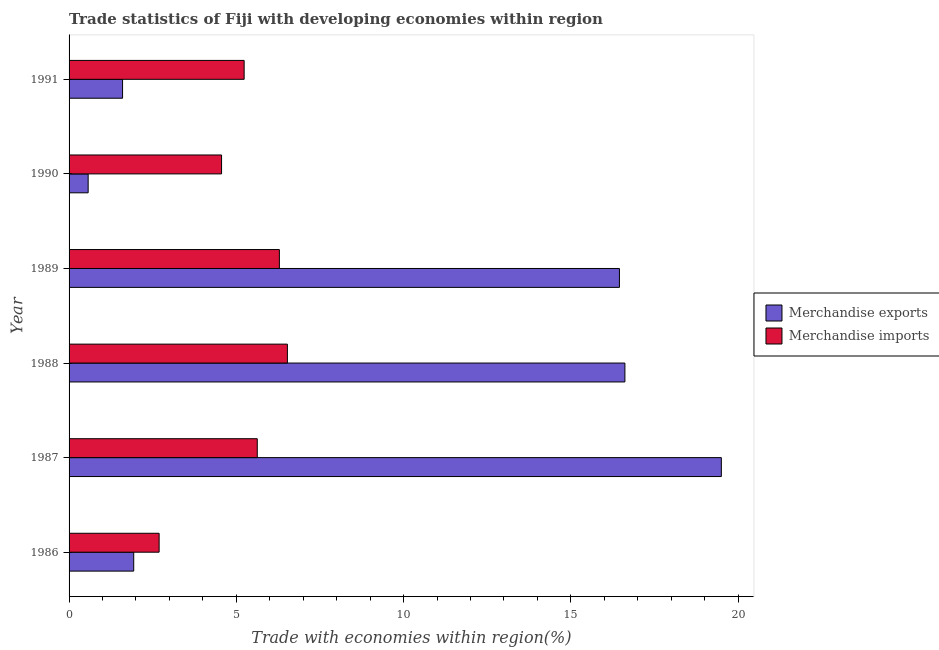How many different coloured bars are there?
Your response must be concise. 2. How many groups of bars are there?
Make the answer very short. 6. Are the number of bars on each tick of the Y-axis equal?
Give a very brief answer. Yes. How many bars are there on the 3rd tick from the top?
Provide a succinct answer. 2. In how many cases, is the number of bars for a given year not equal to the number of legend labels?
Provide a short and direct response. 0. What is the merchandise imports in 1987?
Keep it short and to the point. 5.63. Across all years, what is the maximum merchandise imports?
Your answer should be compact. 6.53. Across all years, what is the minimum merchandise imports?
Your answer should be very brief. 2.69. What is the total merchandise exports in the graph?
Keep it short and to the point. 56.67. What is the difference between the merchandise exports in 1987 and that in 1989?
Ensure brevity in your answer.  3.05. What is the difference between the merchandise exports in 1990 and the merchandise imports in 1987?
Ensure brevity in your answer.  -5.06. What is the average merchandise imports per year?
Give a very brief answer. 5.15. In the year 1987, what is the difference between the merchandise exports and merchandise imports?
Provide a succinct answer. 13.87. What is the ratio of the merchandise exports in 1988 to that in 1989?
Provide a short and direct response. 1.01. Is the merchandise imports in 1986 less than that in 1991?
Provide a short and direct response. Yes. What is the difference between the highest and the second highest merchandise imports?
Your answer should be compact. 0.24. What is the difference between the highest and the lowest merchandise exports?
Your response must be concise. 18.93. In how many years, is the merchandise exports greater than the average merchandise exports taken over all years?
Offer a terse response. 3. Is the sum of the merchandise exports in 1986 and 1989 greater than the maximum merchandise imports across all years?
Provide a short and direct response. Yes. What does the 2nd bar from the top in 1989 represents?
Provide a short and direct response. Merchandise exports. What does the 2nd bar from the bottom in 1986 represents?
Offer a very short reply. Merchandise imports. How many bars are there?
Offer a very short reply. 12. Are all the bars in the graph horizontal?
Your response must be concise. Yes. Does the graph contain any zero values?
Your answer should be very brief. No. Does the graph contain grids?
Make the answer very short. No. How are the legend labels stacked?
Provide a succinct answer. Vertical. What is the title of the graph?
Your response must be concise. Trade statistics of Fiji with developing economies within region. Does "Export" appear as one of the legend labels in the graph?
Your answer should be compact. No. What is the label or title of the X-axis?
Offer a terse response. Trade with economies within region(%). What is the Trade with economies within region(%) of Merchandise exports in 1986?
Make the answer very short. 1.93. What is the Trade with economies within region(%) of Merchandise imports in 1986?
Provide a short and direct response. 2.69. What is the Trade with economies within region(%) in Merchandise exports in 1987?
Your answer should be very brief. 19.5. What is the Trade with economies within region(%) in Merchandise imports in 1987?
Give a very brief answer. 5.63. What is the Trade with economies within region(%) in Merchandise exports in 1988?
Keep it short and to the point. 16.62. What is the Trade with economies within region(%) in Merchandise imports in 1988?
Your answer should be compact. 6.53. What is the Trade with economies within region(%) in Merchandise exports in 1989?
Your response must be concise. 16.45. What is the Trade with economies within region(%) of Merchandise imports in 1989?
Provide a short and direct response. 6.29. What is the Trade with economies within region(%) in Merchandise exports in 1990?
Your answer should be compact. 0.57. What is the Trade with economies within region(%) of Merchandise imports in 1990?
Your answer should be very brief. 4.56. What is the Trade with economies within region(%) of Merchandise exports in 1991?
Provide a succinct answer. 1.6. What is the Trade with economies within region(%) in Merchandise imports in 1991?
Provide a succinct answer. 5.23. Across all years, what is the maximum Trade with economies within region(%) of Merchandise exports?
Make the answer very short. 19.5. Across all years, what is the maximum Trade with economies within region(%) of Merchandise imports?
Your answer should be compact. 6.53. Across all years, what is the minimum Trade with economies within region(%) in Merchandise exports?
Your answer should be very brief. 0.57. Across all years, what is the minimum Trade with economies within region(%) of Merchandise imports?
Make the answer very short. 2.69. What is the total Trade with economies within region(%) in Merchandise exports in the graph?
Keep it short and to the point. 56.67. What is the total Trade with economies within region(%) of Merchandise imports in the graph?
Give a very brief answer. 30.92. What is the difference between the Trade with economies within region(%) of Merchandise exports in 1986 and that in 1987?
Make the answer very short. -17.57. What is the difference between the Trade with economies within region(%) in Merchandise imports in 1986 and that in 1987?
Keep it short and to the point. -2.93. What is the difference between the Trade with economies within region(%) of Merchandise exports in 1986 and that in 1988?
Ensure brevity in your answer.  -14.68. What is the difference between the Trade with economies within region(%) in Merchandise imports in 1986 and that in 1988?
Ensure brevity in your answer.  -3.83. What is the difference between the Trade with economies within region(%) in Merchandise exports in 1986 and that in 1989?
Offer a very short reply. -14.52. What is the difference between the Trade with economies within region(%) in Merchandise imports in 1986 and that in 1989?
Your answer should be compact. -3.59. What is the difference between the Trade with economies within region(%) of Merchandise exports in 1986 and that in 1990?
Your answer should be compact. 1.36. What is the difference between the Trade with economies within region(%) in Merchandise imports in 1986 and that in 1990?
Your answer should be compact. -1.87. What is the difference between the Trade with economies within region(%) in Merchandise exports in 1986 and that in 1991?
Your response must be concise. 0.33. What is the difference between the Trade with economies within region(%) of Merchandise imports in 1986 and that in 1991?
Your response must be concise. -2.54. What is the difference between the Trade with economies within region(%) of Merchandise exports in 1987 and that in 1988?
Provide a short and direct response. 2.88. What is the difference between the Trade with economies within region(%) of Merchandise imports in 1987 and that in 1988?
Offer a terse response. -0.9. What is the difference between the Trade with economies within region(%) in Merchandise exports in 1987 and that in 1989?
Give a very brief answer. 3.05. What is the difference between the Trade with economies within region(%) of Merchandise imports in 1987 and that in 1989?
Offer a very short reply. -0.66. What is the difference between the Trade with economies within region(%) in Merchandise exports in 1987 and that in 1990?
Offer a terse response. 18.93. What is the difference between the Trade with economies within region(%) in Merchandise imports in 1987 and that in 1990?
Offer a terse response. 1.07. What is the difference between the Trade with economies within region(%) in Merchandise exports in 1987 and that in 1991?
Make the answer very short. 17.9. What is the difference between the Trade with economies within region(%) of Merchandise imports in 1987 and that in 1991?
Offer a very short reply. 0.39. What is the difference between the Trade with economies within region(%) of Merchandise exports in 1988 and that in 1989?
Give a very brief answer. 0.16. What is the difference between the Trade with economies within region(%) of Merchandise imports in 1988 and that in 1989?
Offer a terse response. 0.24. What is the difference between the Trade with economies within region(%) of Merchandise exports in 1988 and that in 1990?
Ensure brevity in your answer.  16.04. What is the difference between the Trade with economies within region(%) of Merchandise imports in 1988 and that in 1990?
Provide a succinct answer. 1.97. What is the difference between the Trade with economies within region(%) of Merchandise exports in 1988 and that in 1991?
Provide a short and direct response. 15.02. What is the difference between the Trade with economies within region(%) of Merchandise imports in 1988 and that in 1991?
Provide a succinct answer. 1.29. What is the difference between the Trade with economies within region(%) of Merchandise exports in 1989 and that in 1990?
Offer a terse response. 15.88. What is the difference between the Trade with economies within region(%) of Merchandise imports in 1989 and that in 1990?
Your answer should be very brief. 1.73. What is the difference between the Trade with economies within region(%) of Merchandise exports in 1989 and that in 1991?
Provide a short and direct response. 14.85. What is the difference between the Trade with economies within region(%) in Merchandise imports in 1989 and that in 1991?
Offer a terse response. 1.05. What is the difference between the Trade with economies within region(%) of Merchandise exports in 1990 and that in 1991?
Your answer should be compact. -1.03. What is the difference between the Trade with economies within region(%) of Merchandise imports in 1990 and that in 1991?
Your response must be concise. -0.68. What is the difference between the Trade with economies within region(%) in Merchandise exports in 1986 and the Trade with economies within region(%) in Merchandise imports in 1987?
Provide a succinct answer. -3.69. What is the difference between the Trade with economies within region(%) of Merchandise exports in 1986 and the Trade with economies within region(%) of Merchandise imports in 1988?
Ensure brevity in your answer.  -4.59. What is the difference between the Trade with economies within region(%) in Merchandise exports in 1986 and the Trade with economies within region(%) in Merchandise imports in 1989?
Offer a very short reply. -4.35. What is the difference between the Trade with economies within region(%) in Merchandise exports in 1986 and the Trade with economies within region(%) in Merchandise imports in 1990?
Offer a terse response. -2.63. What is the difference between the Trade with economies within region(%) of Merchandise exports in 1986 and the Trade with economies within region(%) of Merchandise imports in 1991?
Provide a succinct answer. -3.3. What is the difference between the Trade with economies within region(%) of Merchandise exports in 1987 and the Trade with economies within region(%) of Merchandise imports in 1988?
Keep it short and to the point. 12.97. What is the difference between the Trade with economies within region(%) of Merchandise exports in 1987 and the Trade with economies within region(%) of Merchandise imports in 1989?
Keep it short and to the point. 13.21. What is the difference between the Trade with economies within region(%) in Merchandise exports in 1987 and the Trade with economies within region(%) in Merchandise imports in 1990?
Make the answer very short. 14.94. What is the difference between the Trade with economies within region(%) in Merchandise exports in 1987 and the Trade with economies within region(%) in Merchandise imports in 1991?
Make the answer very short. 14.26. What is the difference between the Trade with economies within region(%) in Merchandise exports in 1988 and the Trade with economies within region(%) in Merchandise imports in 1989?
Offer a very short reply. 10.33. What is the difference between the Trade with economies within region(%) of Merchandise exports in 1988 and the Trade with economies within region(%) of Merchandise imports in 1990?
Provide a succinct answer. 12.06. What is the difference between the Trade with economies within region(%) in Merchandise exports in 1988 and the Trade with economies within region(%) in Merchandise imports in 1991?
Your answer should be compact. 11.38. What is the difference between the Trade with economies within region(%) in Merchandise exports in 1989 and the Trade with economies within region(%) in Merchandise imports in 1990?
Your response must be concise. 11.89. What is the difference between the Trade with economies within region(%) in Merchandise exports in 1989 and the Trade with economies within region(%) in Merchandise imports in 1991?
Your answer should be compact. 11.22. What is the difference between the Trade with economies within region(%) in Merchandise exports in 1990 and the Trade with economies within region(%) in Merchandise imports in 1991?
Ensure brevity in your answer.  -4.66. What is the average Trade with economies within region(%) in Merchandise exports per year?
Provide a short and direct response. 9.44. What is the average Trade with economies within region(%) in Merchandise imports per year?
Offer a very short reply. 5.15. In the year 1986, what is the difference between the Trade with economies within region(%) in Merchandise exports and Trade with economies within region(%) in Merchandise imports?
Offer a terse response. -0.76. In the year 1987, what is the difference between the Trade with economies within region(%) in Merchandise exports and Trade with economies within region(%) in Merchandise imports?
Your answer should be very brief. 13.87. In the year 1988, what is the difference between the Trade with economies within region(%) of Merchandise exports and Trade with economies within region(%) of Merchandise imports?
Keep it short and to the point. 10.09. In the year 1989, what is the difference between the Trade with economies within region(%) of Merchandise exports and Trade with economies within region(%) of Merchandise imports?
Your response must be concise. 10.17. In the year 1990, what is the difference between the Trade with economies within region(%) of Merchandise exports and Trade with economies within region(%) of Merchandise imports?
Offer a terse response. -3.99. In the year 1991, what is the difference between the Trade with economies within region(%) of Merchandise exports and Trade with economies within region(%) of Merchandise imports?
Your answer should be very brief. -3.63. What is the ratio of the Trade with economies within region(%) of Merchandise exports in 1986 to that in 1987?
Your answer should be compact. 0.1. What is the ratio of the Trade with economies within region(%) in Merchandise imports in 1986 to that in 1987?
Provide a short and direct response. 0.48. What is the ratio of the Trade with economies within region(%) of Merchandise exports in 1986 to that in 1988?
Ensure brevity in your answer.  0.12. What is the ratio of the Trade with economies within region(%) of Merchandise imports in 1986 to that in 1988?
Your answer should be very brief. 0.41. What is the ratio of the Trade with economies within region(%) in Merchandise exports in 1986 to that in 1989?
Your response must be concise. 0.12. What is the ratio of the Trade with economies within region(%) in Merchandise imports in 1986 to that in 1989?
Make the answer very short. 0.43. What is the ratio of the Trade with economies within region(%) in Merchandise exports in 1986 to that in 1990?
Offer a terse response. 3.39. What is the ratio of the Trade with economies within region(%) in Merchandise imports in 1986 to that in 1990?
Ensure brevity in your answer.  0.59. What is the ratio of the Trade with economies within region(%) in Merchandise exports in 1986 to that in 1991?
Your answer should be compact. 1.21. What is the ratio of the Trade with economies within region(%) of Merchandise imports in 1986 to that in 1991?
Keep it short and to the point. 0.51. What is the ratio of the Trade with economies within region(%) in Merchandise exports in 1987 to that in 1988?
Make the answer very short. 1.17. What is the ratio of the Trade with economies within region(%) of Merchandise imports in 1987 to that in 1988?
Offer a very short reply. 0.86. What is the ratio of the Trade with economies within region(%) of Merchandise exports in 1987 to that in 1989?
Offer a very short reply. 1.19. What is the ratio of the Trade with economies within region(%) of Merchandise imports in 1987 to that in 1989?
Make the answer very short. 0.89. What is the ratio of the Trade with economies within region(%) of Merchandise exports in 1987 to that in 1990?
Offer a terse response. 34.18. What is the ratio of the Trade with economies within region(%) in Merchandise imports in 1987 to that in 1990?
Ensure brevity in your answer.  1.23. What is the ratio of the Trade with economies within region(%) of Merchandise exports in 1987 to that in 1991?
Offer a terse response. 12.19. What is the ratio of the Trade with economies within region(%) in Merchandise imports in 1987 to that in 1991?
Your response must be concise. 1.07. What is the ratio of the Trade with economies within region(%) of Merchandise exports in 1988 to that in 1989?
Make the answer very short. 1.01. What is the ratio of the Trade with economies within region(%) of Merchandise imports in 1988 to that in 1989?
Your answer should be very brief. 1.04. What is the ratio of the Trade with economies within region(%) of Merchandise exports in 1988 to that in 1990?
Ensure brevity in your answer.  29.12. What is the ratio of the Trade with economies within region(%) in Merchandise imports in 1988 to that in 1990?
Offer a terse response. 1.43. What is the ratio of the Trade with economies within region(%) in Merchandise exports in 1988 to that in 1991?
Keep it short and to the point. 10.39. What is the ratio of the Trade with economies within region(%) in Merchandise imports in 1988 to that in 1991?
Your answer should be very brief. 1.25. What is the ratio of the Trade with economies within region(%) in Merchandise exports in 1989 to that in 1990?
Provide a short and direct response. 28.84. What is the ratio of the Trade with economies within region(%) of Merchandise imports in 1989 to that in 1990?
Your answer should be compact. 1.38. What is the ratio of the Trade with economies within region(%) in Merchandise exports in 1989 to that in 1991?
Make the answer very short. 10.29. What is the ratio of the Trade with economies within region(%) of Merchandise imports in 1989 to that in 1991?
Your response must be concise. 1.2. What is the ratio of the Trade with economies within region(%) of Merchandise exports in 1990 to that in 1991?
Ensure brevity in your answer.  0.36. What is the ratio of the Trade with economies within region(%) of Merchandise imports in 1990 to that in 1991?
Your answer should be very brief. 0.87. What is the difference between the highest and the second highest Trade with economies within region(%) in Merchandise exports?
Provide a short and direct response. 2.88. What is the difference between the highest and the second highest Trade with economies within region(%) of Merchandise imports?
Keep it short and to the point. 0.24. What is the difference between the highest and the lowest Trade with economies within region(%) of Merchandise exports?
Provide a short and direct response. 18.93. What is the difference between the highest and the lowest Trade with economies within region(%) of Merchandise imports?
Offer a terse response. 3.83. 